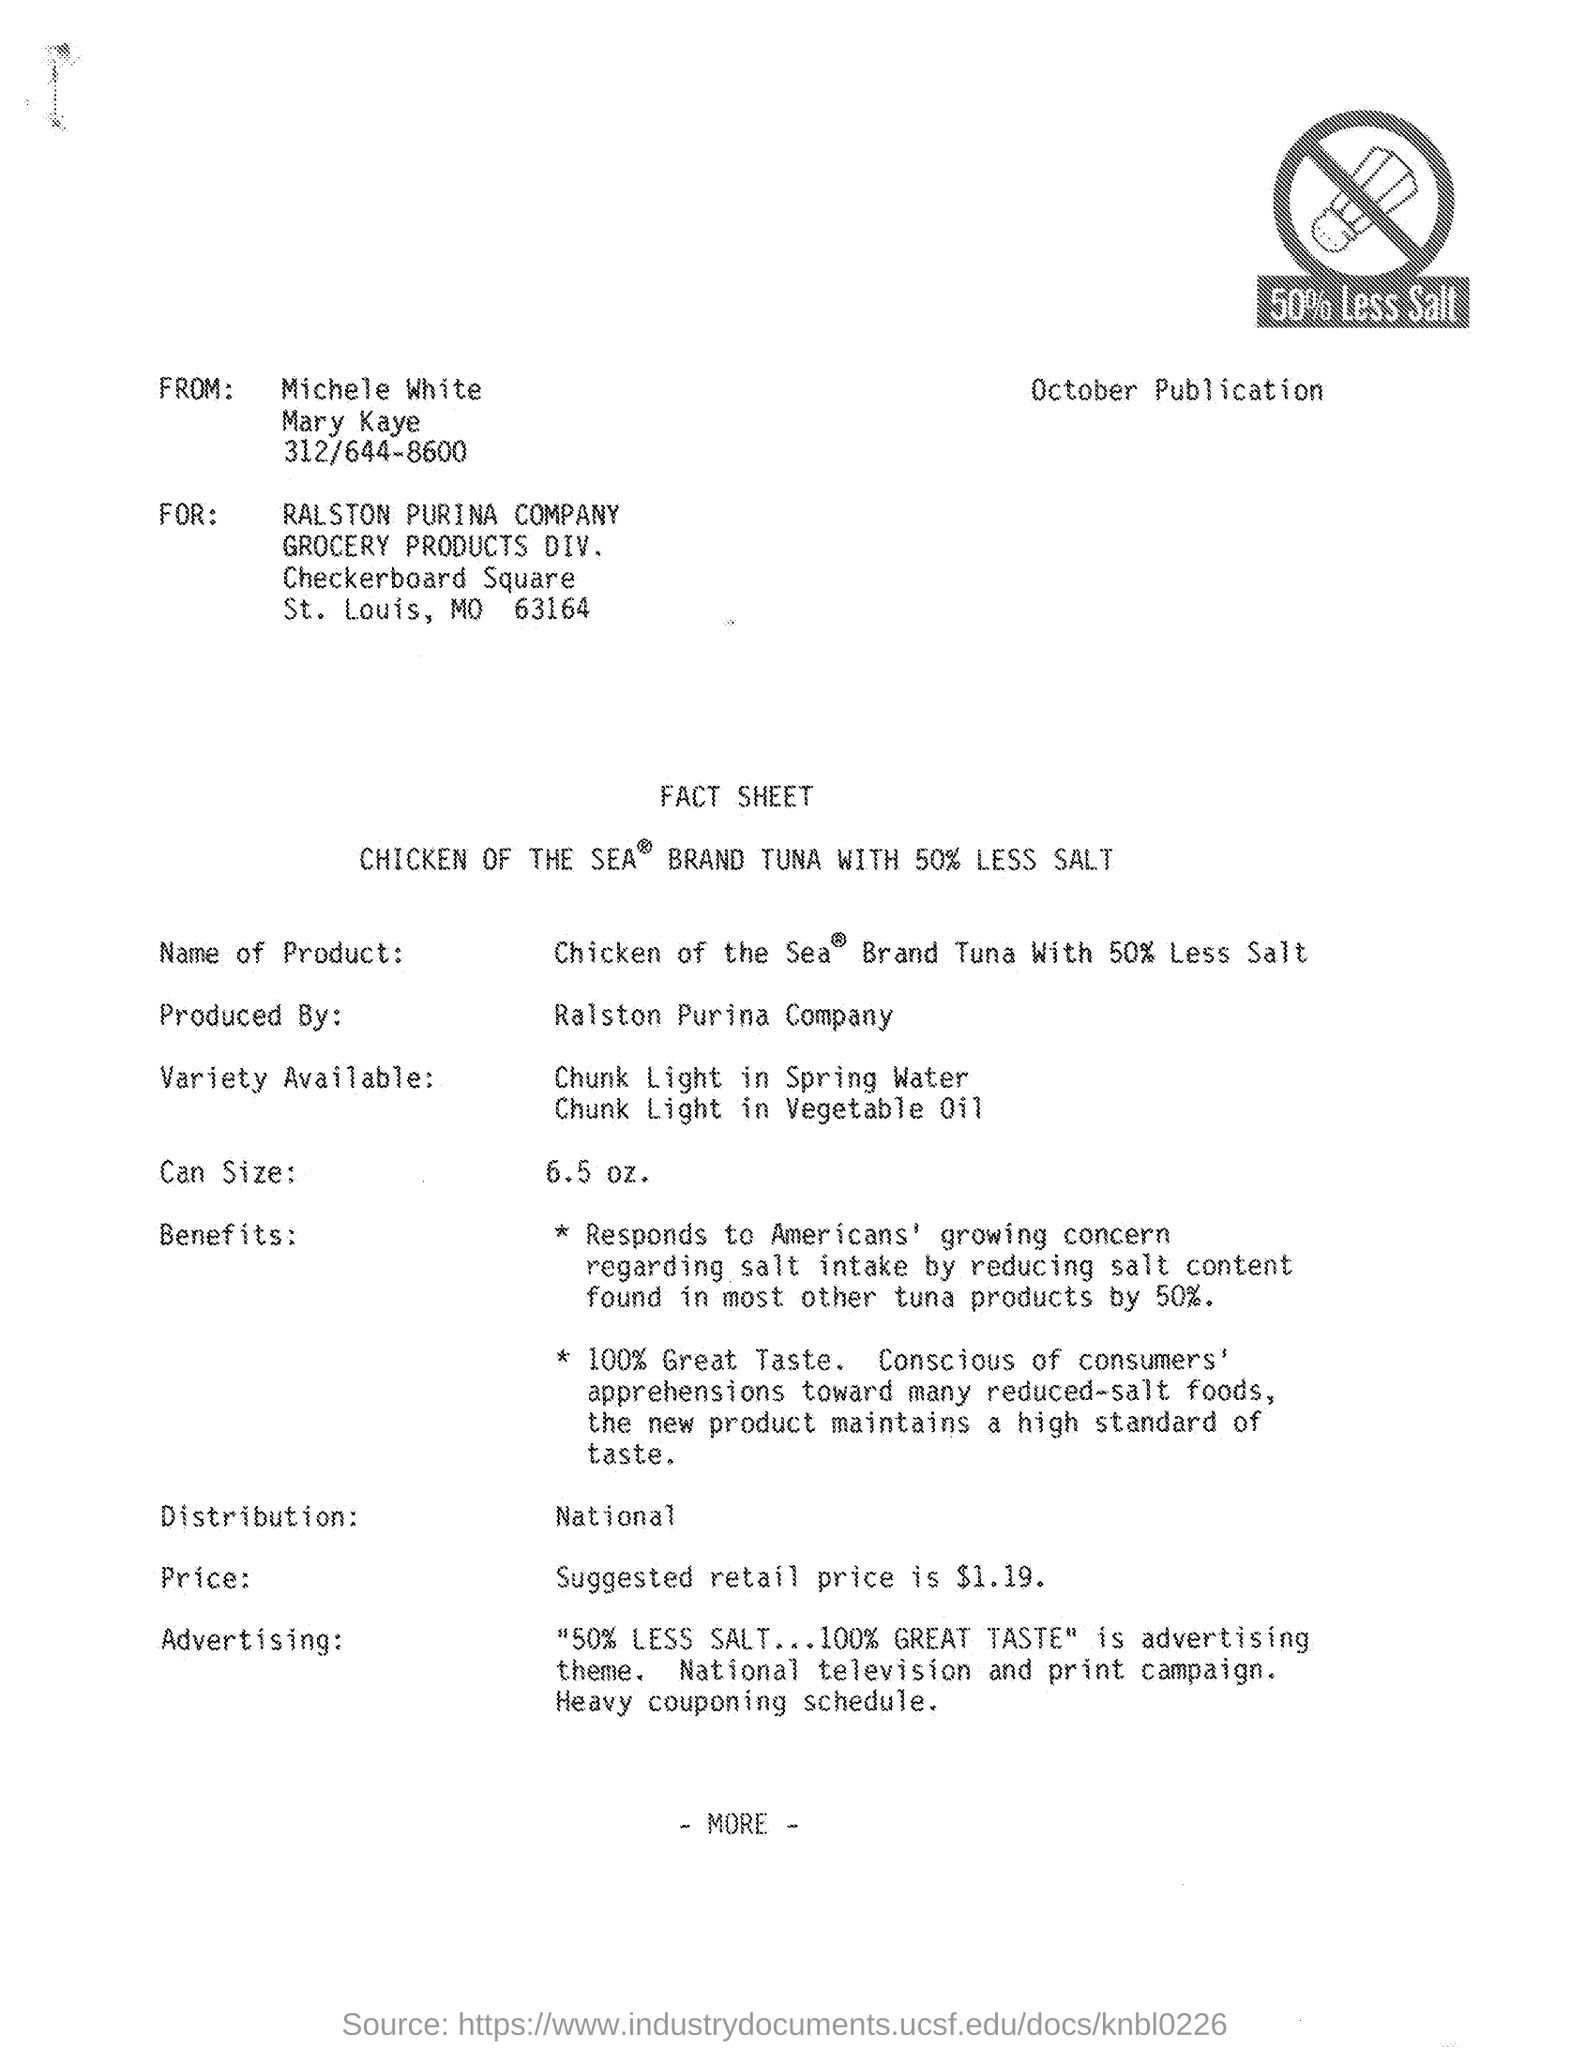what is the can size mentioned in the given fact sheet ? The fact sheet specifies that the can size of Chicken of the Sea brand tuna with 50% less salt is 6.5 ounces. This portion size provides a convenient option for individual servings or small dishes. 